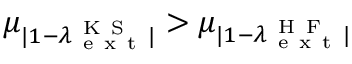Convert formula to latex. <formula><loc_0><loc_0><loc_500><loc_500>\mu _ { | 1 - \lambda _ { e x t } ^ { K S } | } > \mu _ { | 1 - \lambda _ { e x t } ^ { H F } | }</formula> 